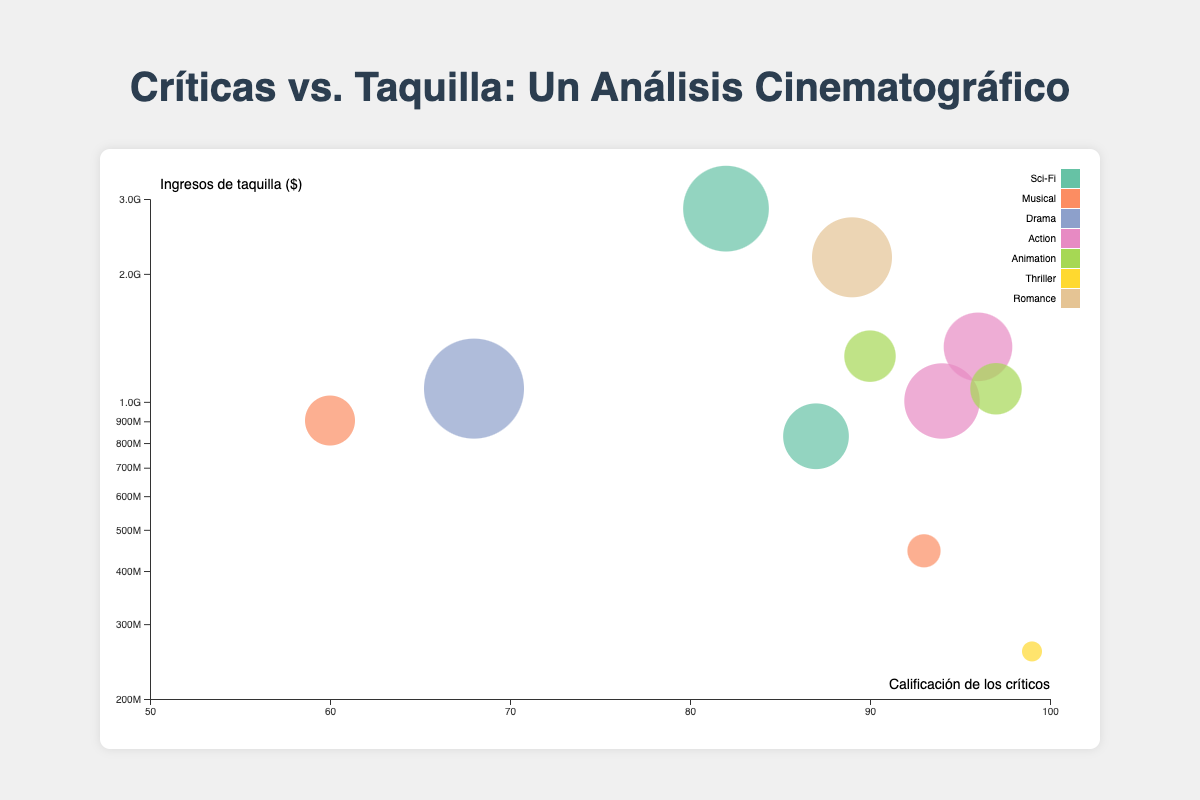What's the title of this figure? The title of the figure is prominently displayed at the top of the page.
Answer: Críticas vs. Taquilla: Un Análisis Cinematográfico Which genre has the bubble with the highest box office revenue? The highest box office revenue corresponds to the bubble representing "Avatar" which is a Sci-Fi movie, indicated by its position farthest to the top-right.
Answer: Sci-Fi How many films have a critics' rating greater than 90? Check the x-axis and count the bubbles to the right of the '90' mark. There are 'La La Land', 'The Dark Knight', 'Black Panther', 'Toy Story 4', and 'Parasite'.
Answer: 5 Compare the box office revenue of 'Joker' and 'Titanic'. Which one is higher? 'Titanic' is positioned higher on the y-axis than 'Joker', indicating it has a higher box office revenue.
Answer: Titanic What is the genre of the film with the highest critics' rating? The film with the highest critics' rating is positioned farthest right on the x-axis, which is "Parasite", and it belongs to the Thriller genre.
Answer: Thriller Which film has the smallest bubble size and what is its genre? The smallest bubble size can be noticed visually and it belongs to "Parasite" which is a Thriller.
Answer: Parasite, Thriller Is there a clear relationship between critics' ratings and box office revenue? Observing the plot, films with both high and low critics' ratings have varying box office revenues, suggesting no clear, direct correlation.
Answer: No Which film from the Action genre has the highest box office revenue? Among the Action genre films, "Black Panther" is positioned highest on the y-axis, indicating the highest box office revenue in that genre.
Answer: Black Panther Between 'Inception' and 'Frozen', which generated higher box office revenue? 'Frozen' is positioned higher on the y-axis than 'Inception', indicating it generated higher box office revenue.
Answer: Frozen What is the average critics' rating for films in the Musical genre? There are two Musical films: 'La La Land' (93) and 'Bohemian Rhapsody' (60). The average is (93 + 60) / 2.
Answer: 76.5 